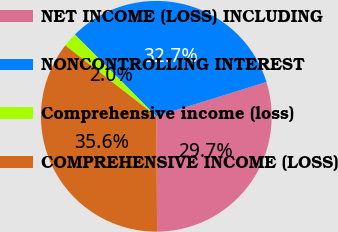Convert chart to OTSL. <chart><loc_0><loc_0><loc_500><loc_500><pie_chart><fcel>NET INCOME (LOSS) INCLUDING<fcel>NONCONTROLLING INTEREST<fcel>Comprehensive income (loss)<fcel>COMPREHENSIVE INCOME (LOSS)<nl><fcel>29.69%<fcel>32.66%<fcel>2.01%<fcel>35.63%<nl></chart> 